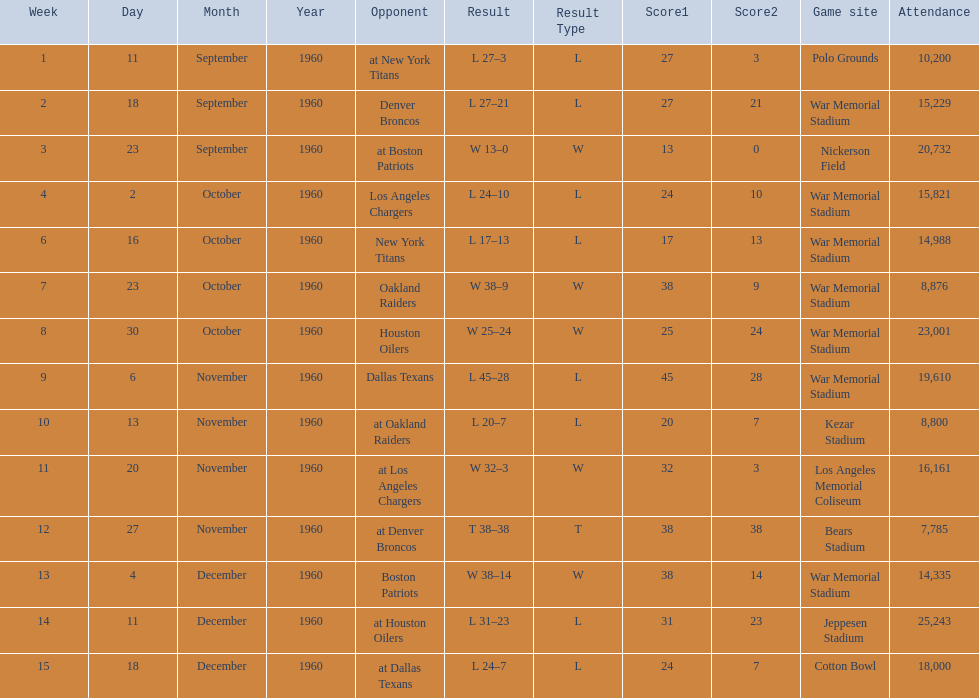The total number of games played at war memorial stadium was how many? 7. 